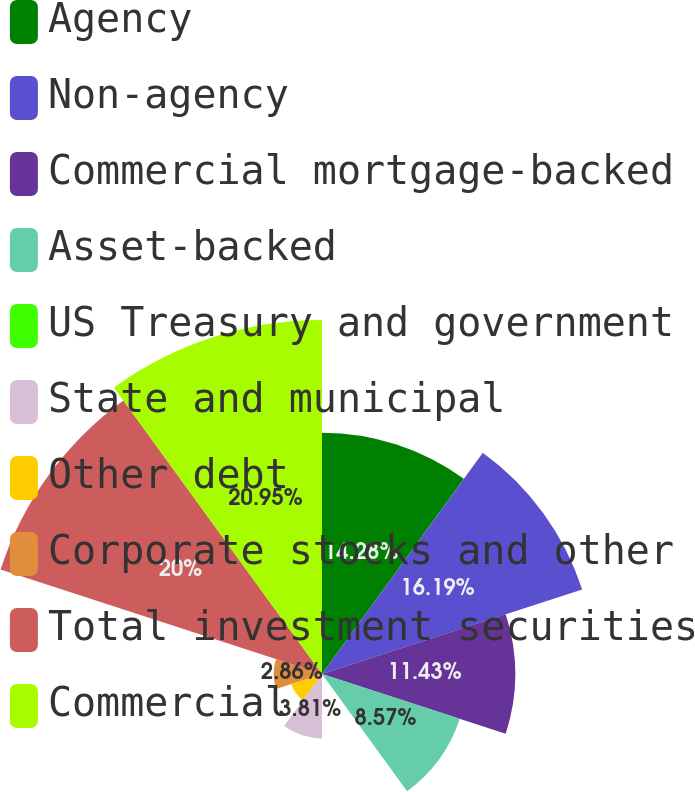Convert chart. <chart><loc_0><loc_0><loc_500><loc_500><pie_chart><fcel>Agency<fcel>Non-agency<fcel>Commercial mortgage-backed<fcel>Asset-backed<fcel>US Treasury and government<fcel>State and municipal<fcel>Other debt<fcel>Corporate stocks and other<fcel>Total investment securities<fcel>Commercial<nl><fcel>14.28%<fcel>16.19%<fcel>11.43%<fcel>8.57%<fcel>0.0%<fcel>3.81%<fcel>1.91%<fcel>2.86%<fcel>20.0%<fcel>20.95%<nl></chart> 